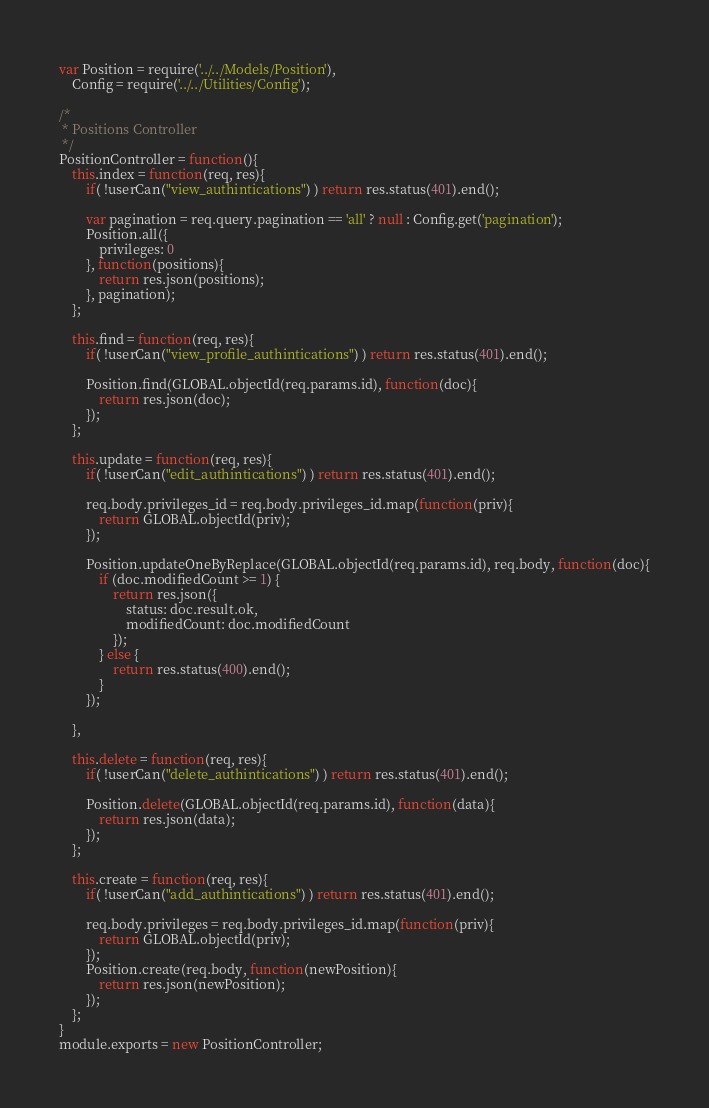<code> <loc_0><loc_0><loc_500><loc_500><_JavaScript_>var Position = require('../../Models/Position'),
    Config = require('../../Utilities/Config');

/*
 * Positions Controller
 */
PositionController = function(){
    this.index = function(req, res){
        if( !userCan("view_authintications") ) return res.status(401).end();

        var pagination = req.query.pagination == 'all' ? null : Config.get('pagination');
        Position.all({
            privileges: 0
        }, function(positions){
            return res.json(positions);
        }, pagination);
    };

    this.find = function(req, res){
        if( !userCan("view_profile_authintications") ) return res.status(401).end();

        Position.find(GLOBAL.objectId(req.params.id), function(doc){
            return res.json(doc);
        });
    };

    this.update = function(req, res){
        if( !userCan("edit_authintications") ) return res.status(401).end();

        req.body.privileges_id = req.body.privileges_id.map(function(priv){
            return GLOBAL.objectId(priv);
        });

        Position.updateOneByReplace(GLOBAL.objectId(req.params.id), req.body, function(doc){
            if (doc.modifiedCount >= 1) {
                return res.json({
                    status: doc.result.ok,
                    modifiedCount: doc.modifiedCount
                });
            } else {
                return res.status(400).end();
            }
        });

    },

    this.delete = function(req, res){
        if( !userCan("delete_authintications") ) return res.status(401).end();

        Position.delete(GLOBAL.objectId(req.params.id), function(data){
            return res.json(data);
        });
    };

    this.create = function(req, res){
        if( !userCan("add_authintications") ) return res.status(401).end();

        req.body.privileges = req.body.privileges_id.map(function(priv){
            return GLOBAL.objectId(priv);
        });
        Position.create(req.body, function(newPosition){
            return res.json(newPosition);
        });
    };
}
module.exports = new PositionController;
</code> 